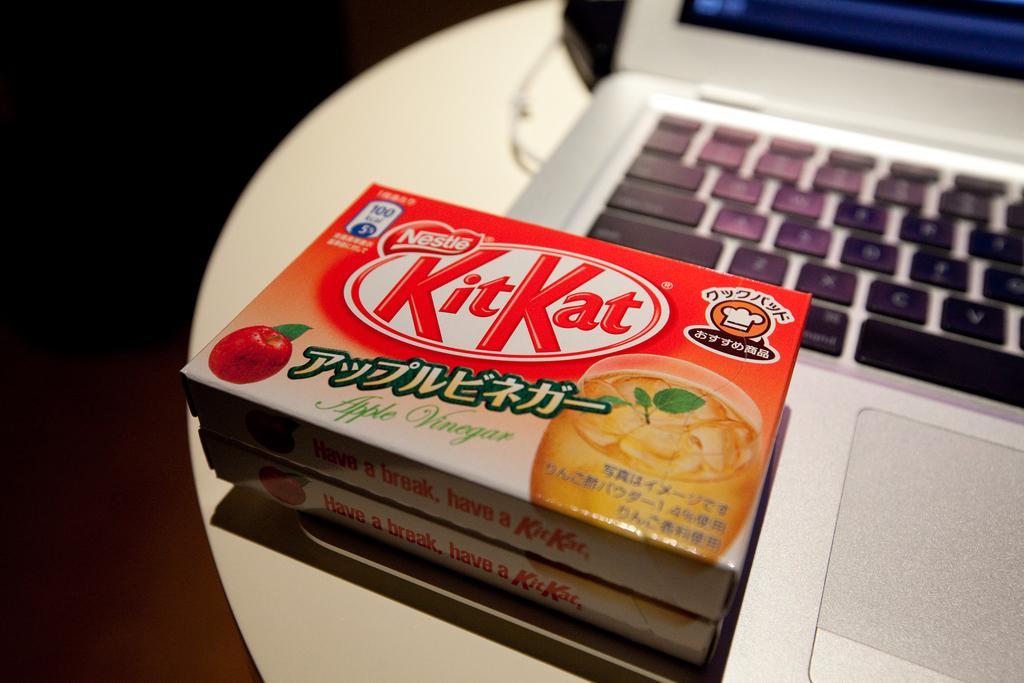Please provide a concise description of this image. In this image we can see a table, on the table there is a laptop and on there are boxes on the laptop. 